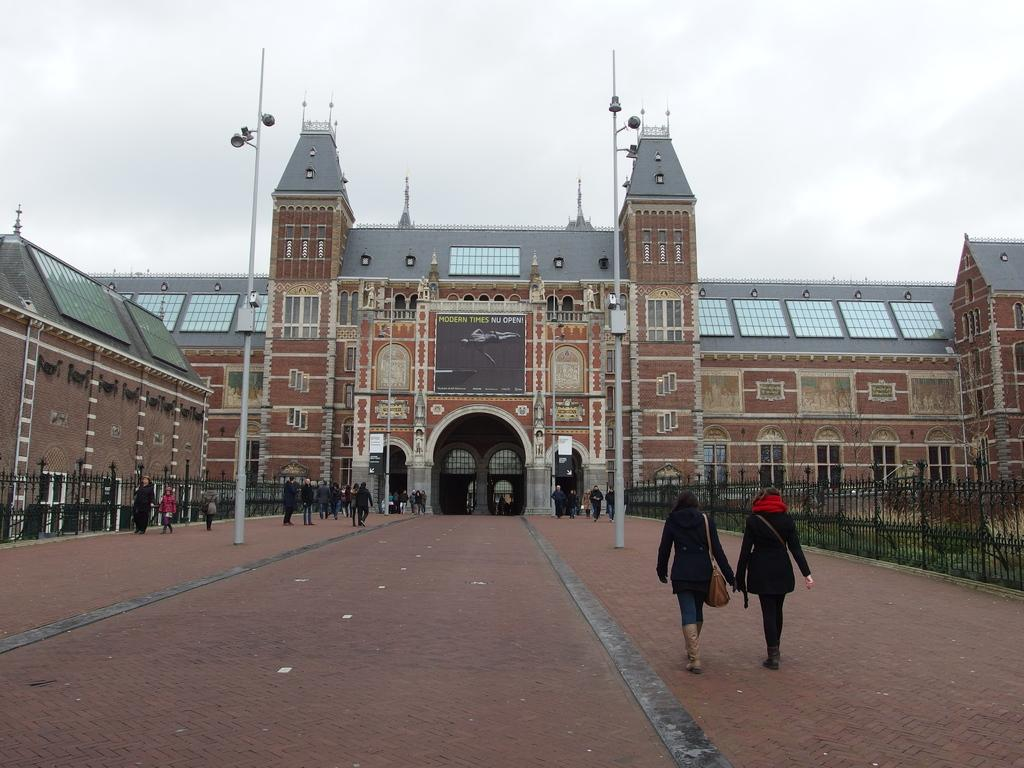What type of structures can be seen in the image? There are buildings in the image. What are the light poles used for in the image? The light poles provide illumination in the image. What can people walk on in the image? There is a footpath in the image for people to walk on. What separates the area in the image? A fence is visible in the image. What type of vegetation is present in the image? Grass is present in the image. What is the color of the sky in the image? The sky is white in the image. What are the people in the image doing? People are walking in the image. What are the people wearing? The people are wearing clothes. What accessory can be seen in the image? There is a handbag in the image. How many buns are being carried by the snake in the image? There is no snake or bun present in the image. What type of crate is visible in the image? There is no crate present in the image. 